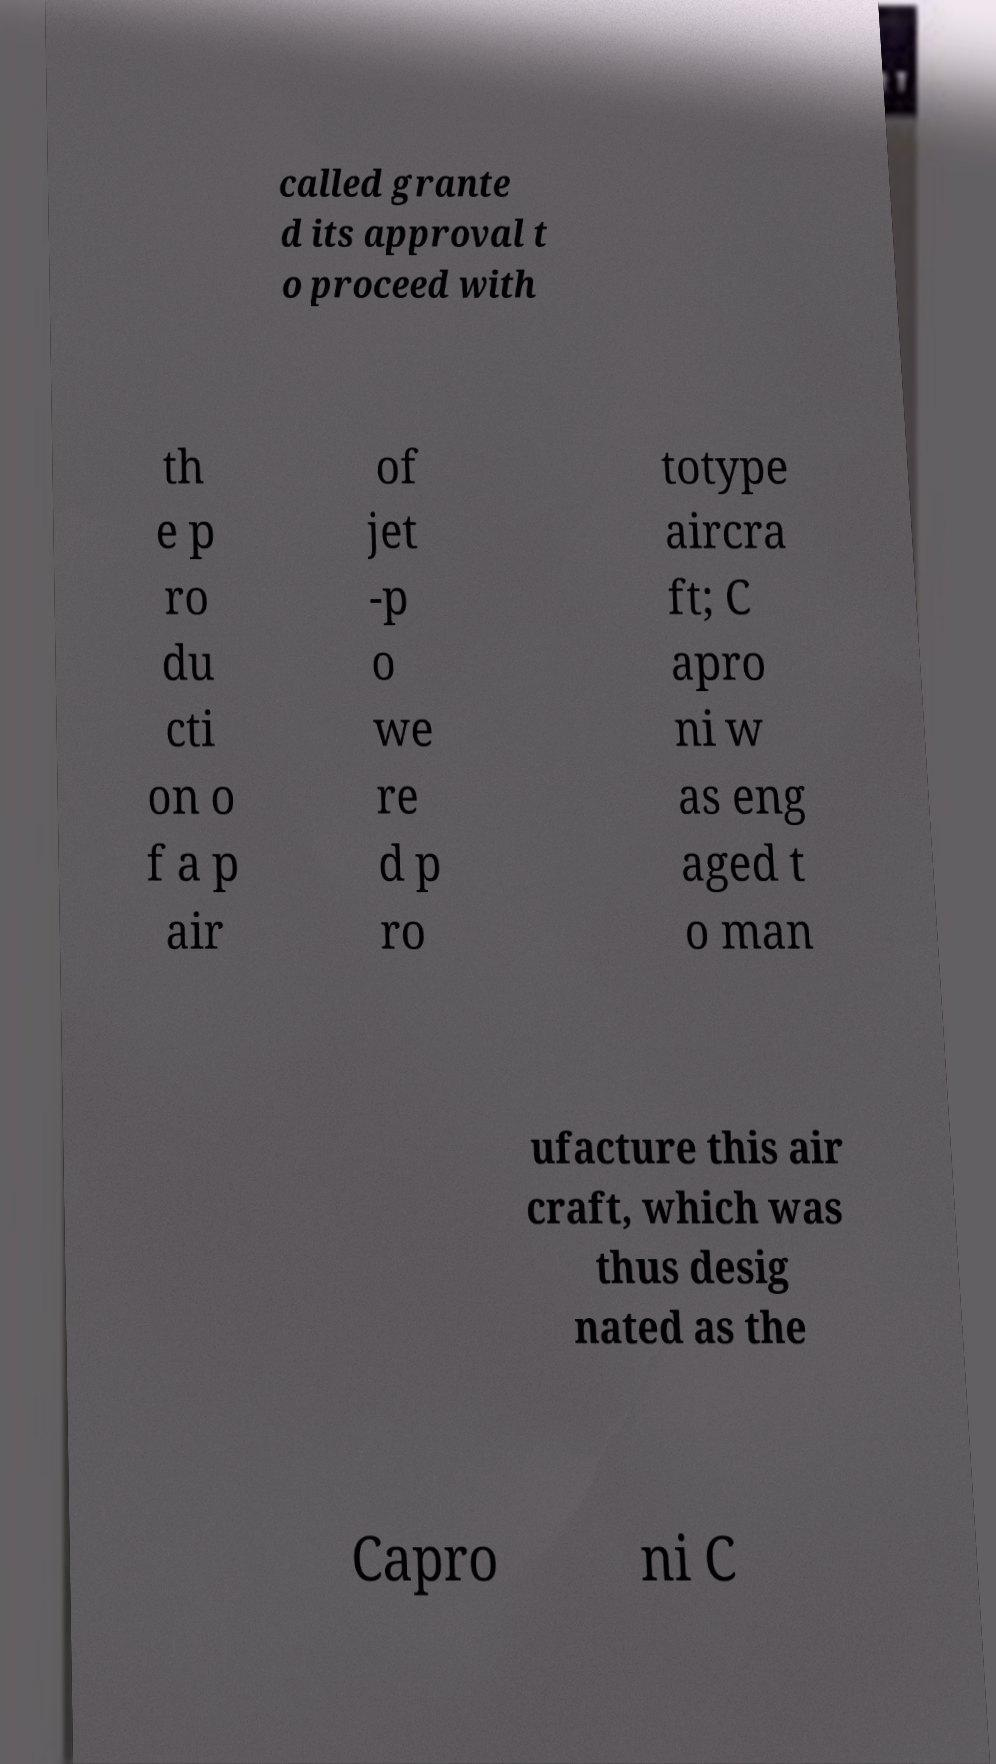I need the written content from this picture converted into text. Can you do that? called grante d its approval t o proceed with th e p ro du cti on o f a p air of jet -p o we re d p ro totype aircra ft; C apro ni w as eng aged t o man ufacture this air craft, which was thus desig nated as the Capro ni C 